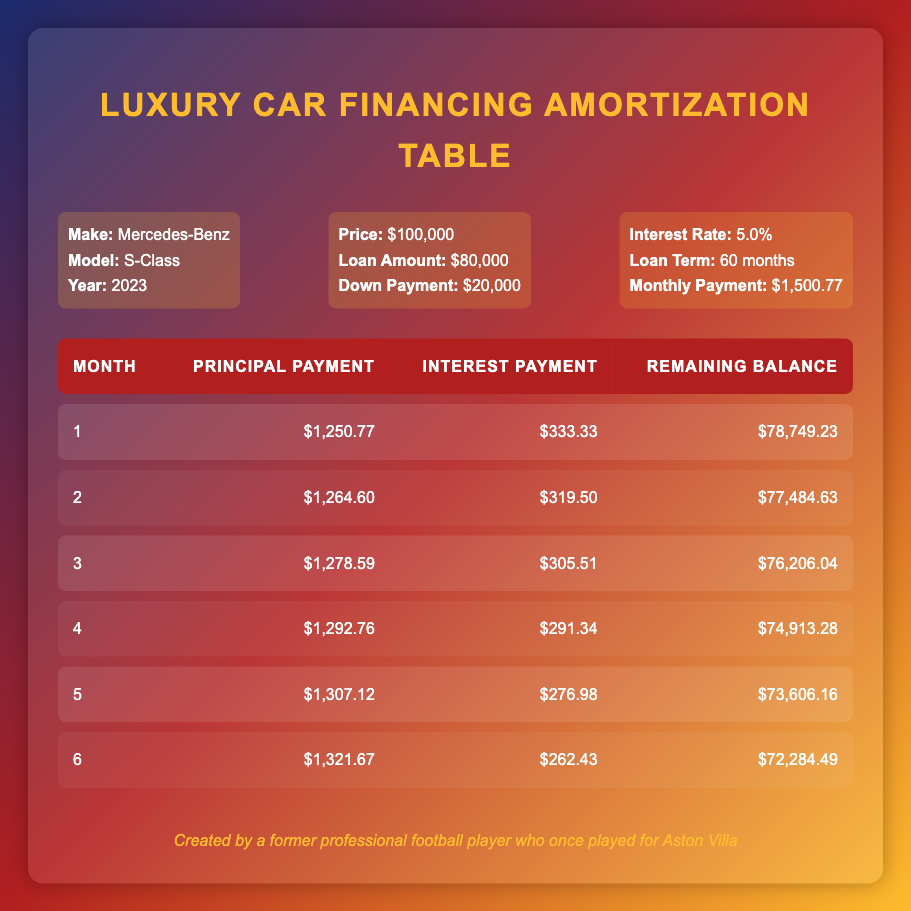What is the monthly payment for the financing deal? The monthly payment is stated as $1,500.77 directly in the financing details provided.
Answer: 1,500.77 How much is the total principal payment made in the first 3 months? To find the total principal payment for the first three months, add the principal payments for each month: 1250.77 + 1264.60 + 1278.59 = 3793.96.
Answer: 3793.96 Is the interest payment for the first month higher than $300? The interest payment for the first month is $333.33, which is greater than $300.
Answer: Yes What is the remaining balance after the second month? The remaining balance after the second month is listed as $77,484.63 in the payment breakdown for month 2.
Answer: 77,484.63 In which month does the principal payment first exceed $1,300? To answer this, we look at the principal payments: Month 1 is 1250.77, Month 2 is 1264.60, Month 3 is 1278.59, Month 4 is 1292.76, Month 5 is 1307.12. Month 5 is the first instance where the principal payment exceeds 1300.
Answer: Month 5 What is the average monthly interest payment over the first 6 months? To find the average, sum the interest payments for the first 6 months: 333.33 + 319.50 + 305.51 + 291.34 + 276.98 + 262.43 = 1,788.09. Divide this by 6 to get the average: 1,788.09 / 6 = 298.01.
Answer: 298.01 How much of the total payment is going towards principal after 6 months? First, we sum the principal payments for all 6 months: 1250.77 + 1264.60 + 1278.59 + 1292.76 + 1307.12 + 1321.67 = 6,735.51. Thus, after 6 months, a total of $6,735.51 has gone towards the principal.
Answer: 6,735.51 Did the remaining balance decrease steadily over the first 6 months? By examining the remaining balances month by month, we see they decrease as follows: 78,749.23 -> 77,484.63 -> 76,206.04 -> 74,913.28 -> 73,606.16 -> 72,284.49; this shows a steady decrease.
Answer: Yes 